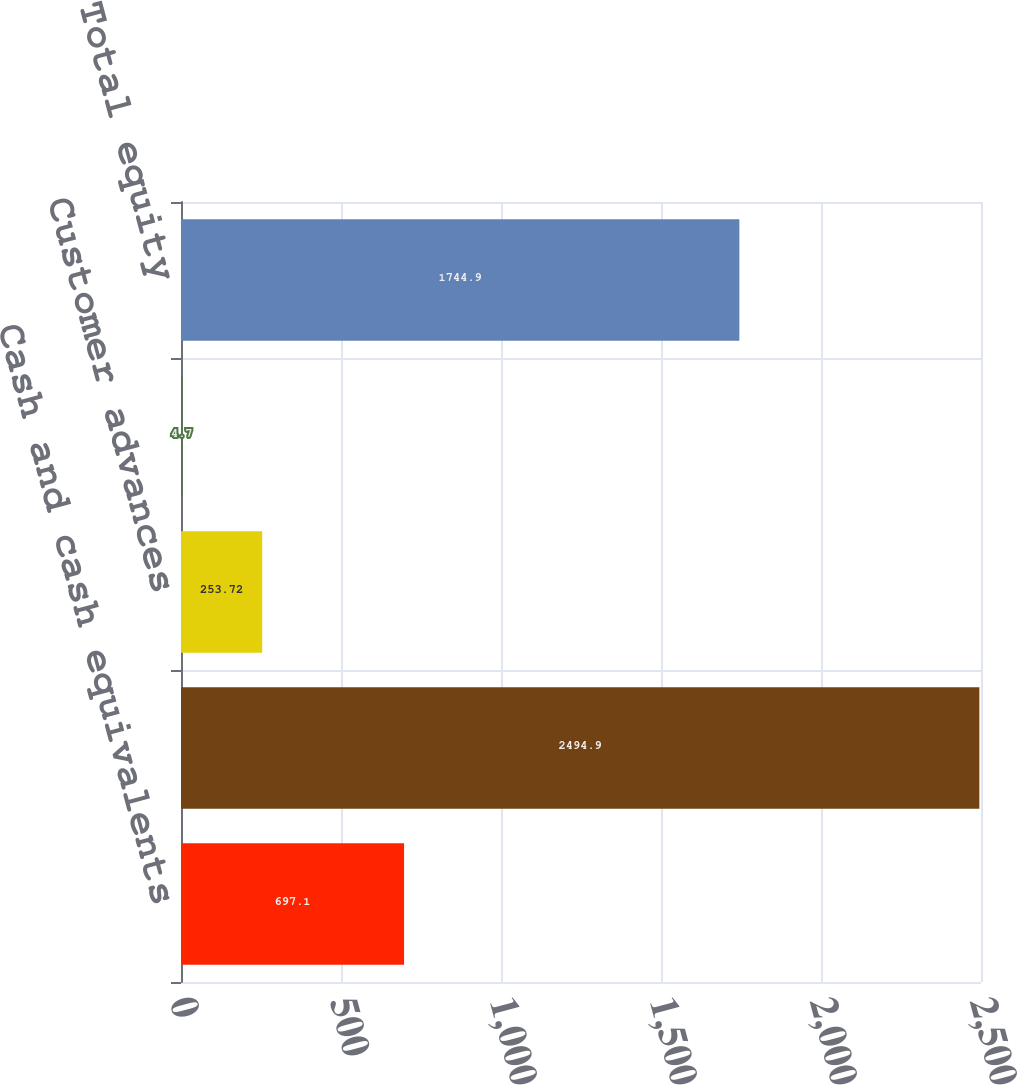Convert chart to OTSL. <chart><loc_0><loc_0><loc_500><loc_500><bar_chart><fcel>Cash and cash equivalents<fcel>Total assets<fcel>Customer advances<fcel>Total debt<fcel>Total equity<nl><fcel>697.1<fcel>2494.9<fcel>253.72<fcel>4.7<fcel>1744.9<nl></chart> 